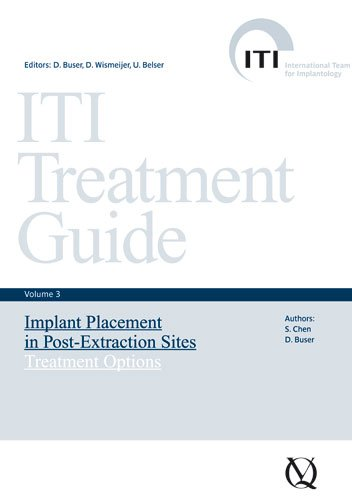Who is the target audience for this book? The target audience includes dental surgeons, periodontists, and any medical professionals involved in the placement of dental implants, providing them with advanced guidance and procedural knowledge. 